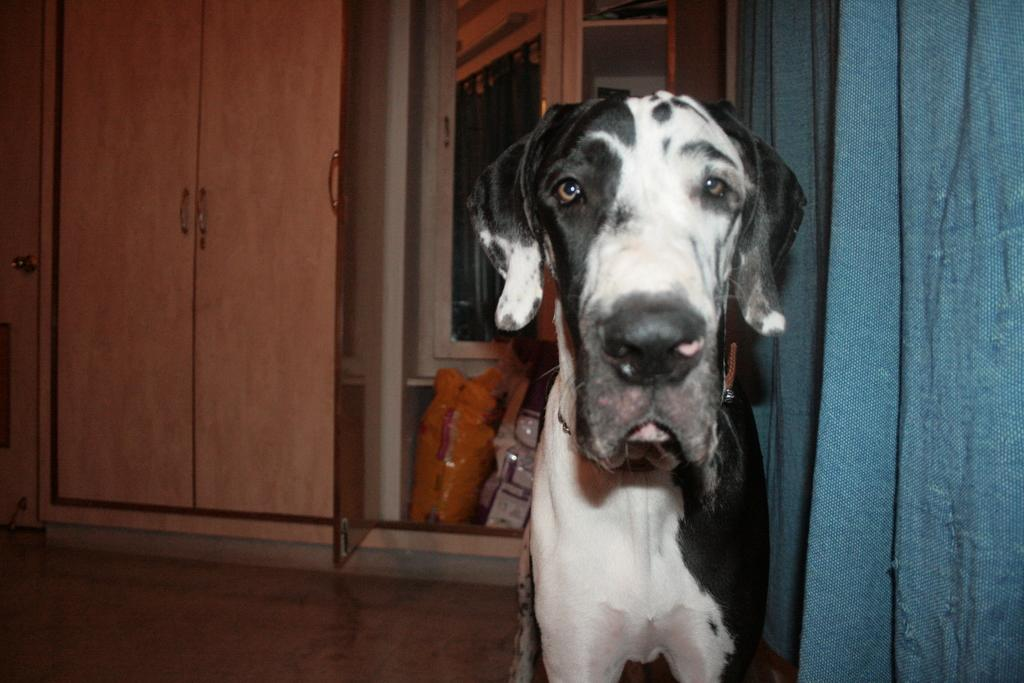What animal can be seen in the image? There is a dog in the image. Where is the dog positioned in the image? The dog is standing on the floor. What is located beside the dog? There is a curtain beside the dog. What type of furniture can be seen in the background of the image? There are cupboards in the background of the image. What type of powder is being used by the dog in the image? There is no powder present in the image, and the dog is not using any substance. 